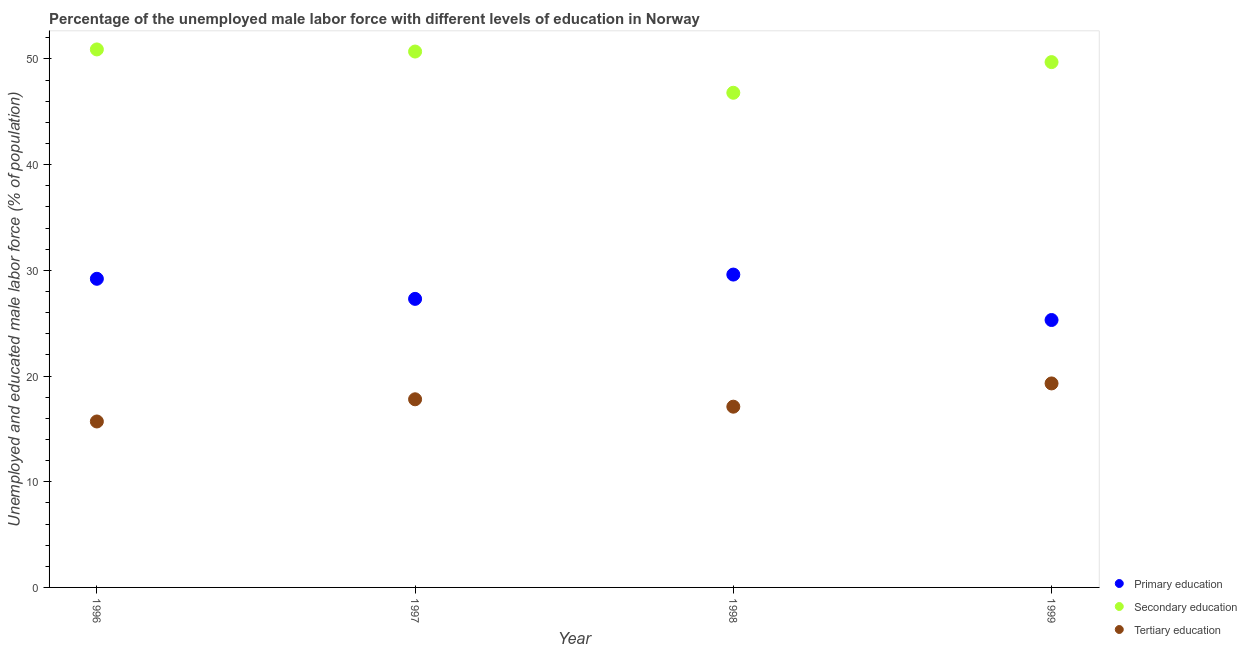What is the percentage of male labor force who received secondary education in 1997?
Your answer should be compact. 50.7. Across all years, what is the maximum percentage of male labor force who received primary education?
Your answer should be compact. 29.6. Across all years, what is the minimum percentage of male labor force who received secondary education?
Offer a terse response. 46.8. In which year was the percentage of male labor force who received primary education maximum?
Your answer should be very brief. 1998. What is the total percentage of male labor force who received secondary education in the graph?
Give a very brief answer. 198.1. What is the difference between the percentage of male labor force who received primary education in 1997 and that in 1998?
Keep it short and to the point. -2.3. What is the difference between the percentage of male labor force who received secondary education in 1996 and the percentage of male labor force who received tertiary education in 1998?
Ensure brevity in your answer.  33.8. What is the average percentage of male labor force who received secondary education per year?
Your response must be concise. 49.53. In the year 1998, what is the difference between the percentage of male labor force who received secondary education and percentage of male labor force who received primary education?
Ensure brevity in your answer.  17.2. What is the ratio of the percentage of male labor force who received tertiary education in 1997 to that in 1999?
Make the answer very short. 0.92. Is the percentage of male labor force who received tertiary education in 1996 less than that in 1998?
Keep it short and to the point. Yes. Is the difference between the percentage of male labor force who received secondary education in 1996 and 1997 greater than the difference between the percentage of male labor force who received tertiary education in 1996 and 1997?
Your answer should be very brief. Yes. What is the difference between the highest and the lowest percentage of male labor force who received secondary education?
Give a very brief answer. 4.1. Is the percentage of male labor force who received primary education strictly greater than the percentage of male labor force who received secondary education over the years?
Provide a succinct answer. No. How many years are there in the graph?
Offer a terse response. 4. What is the difference between two consecutive major ticks on the Y-axis?
Offer a very short reply. 10. Are the values on the major ticks of Y-axis written in scientific E-notation?
Provide a short and direct response. No. Does the graph contain any zero values?
Provide a succinct answer. No. Does the graph contain grids?
Keep it short and to the point. No. How many legend labels are there?
Make the answer very short. 3. How are the legend labels stacked?
Ensure brevity in your answer.  Vertical. What is the title of the graph?
Your answer should be very brief. Percentage of the unemployed male labor force with different levels of education in Norway. What is the label or title of the Y-axis?
Provide a short and direct response. Unemployed and educated male labor force (% of population). What is the Unemployed and educated male labor force (% of population) of Primary education in 1996?
Your answer should be compact. 29.2. What is the Unemployed and educated male labor force (% of population) of Secondary education in 1996?
Provide a short and direct response. 50.9. What is the Unemployed and educated male labor force (% of population) of Tertiary education in 1996?
Keep it short and to the point. 15.7. What is the Unemployed and educated male labor force (% of population) in Primary education in 1997?
Your answer should be very brief. 27.3. What is the Unemployed and educated male labor force (% of population) in Secondary education in 1997?
Provide a short and direct response. 50.7. What is the Unemployed and educated male labor force (% of population) in Tertiary education in 1997?
Make the answer very short. 17.8. What is the Unemployed and educated male labor force (% of population) in Primary education in 1998?
Give a very brief answer. 29.6. What is the Unemployed and educated male labor force (% of population) in Secondary education in 1998?
Keep it short and to the point. 46.8. What is the Unemployed and educated male labor force (% of population) in Tertiary education in 1998?
Your answer should be very brief. 17.1. What is the Unemployed and educated male labor force (% of population) of Primary education in 1999?
Offer a very short reply. 25.3. What is the Unemployed and educated male labor force (% of population) of Secondary education in 1999?
Make the answer very short. 49.7. What is the Unemployed and educated male labor force (% of population) of Tertiary education in 1999?
Offer a very short reply. 19.3. Across all years, what is the maximum Unemployed and educated male labor force (% of population) of Primary education?
Your answer should be compact. 29.6. Across all years, what is the maximum Unemployed and educated male labor force (% of population) of Secondary education?
Offer a terse response. 50.9. Across all years, what is the maximum Unemployed and educated male labor force (% of population) of Tertiary education?
Ensure brevity in your answer.  19.3. Across all years, what is the minimum Unemployed and educated male labor force (% of population) of Primary education?
Give a very brief answer. 25.3. Across all years, what is the minimum Unemployed and educated male labor force (% of population) in Secondary education?
Make the answer very short. 46.8. Across all years, what is the minimum Unemployed and educated male labor force (% of population) of Tertiary education?
Your response must be concise. 15.7. What is the total Unemployed and educated male labor force (% of population) of Primary education in the graph?
Make the answer very short. 111.4. What is the total Unemployed and educated male labor force (% of population) of Secondary education in the graph?
Provide a short and direct response. 198.1. What is the total Unemployed and educated male labor force (% of population) of Tertiary education in the graph?
Your answer should be compact. 69.9. What is the difference between the Unemployed and educated male labor force (% of population) of Primary education in 1996 and that in 1997?
Offer a terse response. 1.9. What is the difference between the Unemployed and educated male labor force (% of population) of Primary education in 1996 and that in 1999?
Give a very brief answer. 3.9. What is the difference between the Unemployed and educated male labor force (% of population) of Primary education in 1997 and that in 1999?
Provide a short and direct response. 2. What is the difference between the Unemployed and educated male labor force (% of population) in Secondary education in 1997 and that in 1999?
Offer a terse response. 1. What is the difference between the Unemployed and educated male labor force (% of population) of Tertiary education in 1997 and that in 1999?
Ensure brevity in your answer.  -1.5. What is the difference between the Unemployed and educated male labor force (% of population) in Primary education in 1998 and that in 1999?
Offer a very short reply. 4.3. What is the difference between the Unemployed and educated male labor force (% of population) in Secondary education in 1998 and that in 1999?
Keep it short and to the point. -2.9. What is the difference between the Unemployed and educated male labor force (% of population) in Tertiary education in 1998 and that in 1999?
Give a very brief answer. -2.2. What is the difference between the Unemployed and educated male labor force (% of population) in Primary education in 1996 and the Unemployed and educated male labor force (% of population) in Secondary education in 1997?
Offer a very short reply. -21.5. What is the difference between the Unemployed and educated male labor force (% of population) of Primary education in 1996 and the Unemployed and educated male labor force (% of population) of Tertiary education in 1997?
Provide a succinct answer. 11.4. What is the difference between the Unemployed and educated male labor force (% of population) of Secondary education in 1996 and the Unemployed and educated male labor force (% of population) of Tertiary education in 1997?
Your response must be concise. 33.1. What is the difference between the Unemployed and educated male labor force (% of population) in Primary education in 1996 and the Unemployed and educated male labor force (% of population) in Secondary education in 1998?
Make the answer very short. -17.6. What is the difference between the Unemployed and educated male labor force (% of population) in Primary education in 1996 and the Unemployed and educated male labor force (% of population) in Tertiary education in 1998?
Give a very brief answer. 12.1. What is the difference between the Unemployed and educated male labor force (% of population) in Secondary education in 1996 and the Unemployed and educated male labor force (% of population) in Tertiary education in 1998?
Your answer should be compact. 33.8. What is the difference between the Unemployed and educated male labor force (% of population) in Primary education in 1996 and the Unemployed and educated male labor force (% of population) in Secondary education in 1999?
Keep it short and to the point. -20.5. What is the difference between the Unemployed and educated male labor force (% of population) of Secondary education in 1996 and the Unemployed and educated male labor force (% of population) of Tertiary education in 1999?
Provide a succinct answer. 31.6. What is the difference between the Unemployed and educated male labor force (% of population) of Primary education in 1997 and the Unemployed and educated male labor force (% of population) of Secondary education in 1998?
Keep it short and to the point. -19.5. What is the difference between the Unemployed and educated male labor force (% of population) of Secondary education in 1997 and the Unemployed and educated male labor force (% of population) of Tertiary education in 1998?
Offer a terse response. 33.6. What is the difference between the Unemployed and educated male labor force (% of population) in Primary education in 1997 and the Unemployed and educated male labor force (% of population) in Secondary education in 1999?
Give a very brief answer. -22.4. What is the difference between the Unemployed and educated male labor force (% of population) of Primary education in 1997 and the Unemployed and educated male labor force (% of population) of Tertiary education in 1999?
Your answer should be very brief. 8. What is the difference between the Unemployed and educated male labor force (% of population) of Secondary education in 1997 and the Unemployed and educated male labor force (% of population) of Tertiary education in 1999?
Provide a short and direct response. 31.4. What is the difference between the Unemployed and educated male labor force (% of population) in Primary education in 1998 and the Unemployed and educated male labor force (% of population) in Secondary education in 1999?
Offer a very short reply. -20.1. What is the difference between the Unemployed and educated male labor force (% of population) in Secondary education in 1998 and the Unemployed and educated male labor force (% of population) in Tertiary education in 1999?
Ensure brevity in your answer.  27.5. What is the average Unemployed and educated male labor force (% of population) in Primary education per year?
Keep it short and to the point. 27.85. What is the average Unemployed and educated male labor force (% of population) of Secondary education per year?
Offer a terse response. 49.52. What is the average Unemployed and educated male labor force (% of population) of Tertiary education per year?
Your answer should be very brief. 17.48. In the year 1996, what is the difference between the Unemployed and educated male labor force (% of population) in Primary education and Unemployed and educated male labor force (% of population) in Secondary education?
Give a very brief answer. -21.7. In the year 1996, what is the difference between the Unemployed and educated male labor force (% of population) of Primary education and Unemployed and educated male labor force (% of population) of Tertiary education?
Offer a very short reply. 13.5. In the year 1996, what is the difference between the Unemployed and educated male labor force (% of population) in Secondary education and Unemployed and educated male labor force (% of population) in Tertiary education?
Make the answer very short. 35.2. In the year 1997, what is the difference between the Unemployed and educated male labor force (% of population) of Primary education and Unemployed and educated male labor force (% of population) of Secondary education?
Provide a short and direct response. -23.4. In the year 1997, what is the difference between the Unemployed and educated male labor force (% of population) of Primary education and Unemployed and educated male labor force (% of population) of Tertiary education?
Make the answer very short. 9.5. In the year 1997, what is the difference between the Unemployed and educated male labor force (% of population) of Secondary education and Unemployed and educated male labor force (% of population) of Tertiary education?
Keep it short and to the point. 32.9. In the year 1998, what is the difference between the Unemployed and educated male labor force (% of population) in Primary education and Unemployed and educated male labor force (% of population) in Secondary education?
Make the answer very short. -17.2. In the year 1998, what is the difference between the Unemployed and educated male labor force (% of population) of Secondary education and Unemployed and educated male labor force (% of population) of Tertiary education?
Offer a terse response. 29.7. In the year 1999, what is the difference between the Unemployed and educated male labor force (% of population) in Primary education and Unemployed and educated male labor force (% of population) in Secondary education?
Your answer should be compact. -24.4. In the year 1999, what is the difference between the Unemployed and educated male labor force (% of population) in Primary education and Unemployed and educated male labor force (% of population) in Tertiary education?
Ensure brevity in your answer.  6. In the year 1999, what is the difference between the Unemployed and educated male labor force (% of population) of Secondary education and Unemployed and educated male labor force (% of population) of Tertiary education?
Your answer should be very brief. 30.4. What is the ratio of the Unemployed and educated male labor force (% of population) of Primary education in 1996 to that in 1997?
Ensure brevity in your answer.  1.07. What is the ratio of the Unemployed and educated male labor force (% of population) of Tertiary education in 1996 to that in 1997?
Provide a succinct answer. 0.88. What is the ratio of the Unemployed and educated male labor force (% of population) in Primary education in 1996 to that in 1998?
Ensure brevity in your answer.  0.99. What is the ratio of the Unemployed and educated male labor force (% of population) in Secondary education in 1996 to that in 1998?
Your answer should be compact. 1.09. What is the ratio of the Unemployed and educated male labor force (% of population) of Tertiary education in 1996 to that in 1998?
Give a very brief answer. 0.92. What is the ratio of the Unemployed and educated male labor force (% of population) in Primary education in 1996 to that in 1999?
Make the answer very short. 1.15. What is the ratio of the Unemployed and educated male labor force (% of population) of Secondary education in 1996 to that in 1999?
Provide a short and direct response. 1.02. What is the ratio of the Unemployed and educated male labor force (% of population) of Tertiary education in 1996 to that in 1999?
Provide a succinct answer. 0.81. What is the ratio of the Unemployed and educated male labor force (% of population) of Primary education in 1997 to that in 1998?
Your response must be concise. 0.92. What is the ratio of the Unemployed and educated male labor force (% of population) in Tertiary education in 1997 to that in 1998?
Give a very brief answer. 1.04. What is the ratio of the Unemployed and educated male labor force (% of population) of Primary education in 1997 to that in 1999?
Your response must be concise. 1.08. What is the ratio of the Unemployed and educated male labor force (% of population) in Secondary education in 1997 to that in 1999?
Ensure brevity in your answer.  1.02. What is the ratio of the Unemployed and educated male labor force (% of population) of Tertiary education in 1997 to that in 1999?
Give a very brief answer. 0.92. What is the ratio of the Unemployed and educated male labor force (% of population) in Primary education in 1998 to that in 1999?
Your answer should be very brief. 1.17. What is the ratio of the Unemployed and educated male labor force (% of population) of Secondary education in 1998 to that in 1999?
Provide a succinct answer. 0.94. What is the ratio of the Unemployed and educated male labor force (% of population) in Tertiary education in 1998 to that in 1999?
Provide a short and direct response. 0.89. What is the difference between the highest and the second highest Unemployed and educated male labor force (% of population) of Primary education?
Ensure brevity in your answer.  0.4. What is the difference between the highest and the second highest Unemployed and educated male labor force (% of population) of Tertiary education?
Give a very brief answer. 1.5. What is the difference between the highest and the lowest Unemployed and educated male labor force (% of population) of Primary education?
Offer a terse response. 4.3. What is the difference between the highest and the lowest Unemployed and educated male labor force (% of population) of Secondary education?
Your answer should be compact. 4.1. What is the difference between the highest and the lowest Unemployed and educated male labor force (% of population) in Tertiary education?
Ensure brevity in your answer.  3.6. 